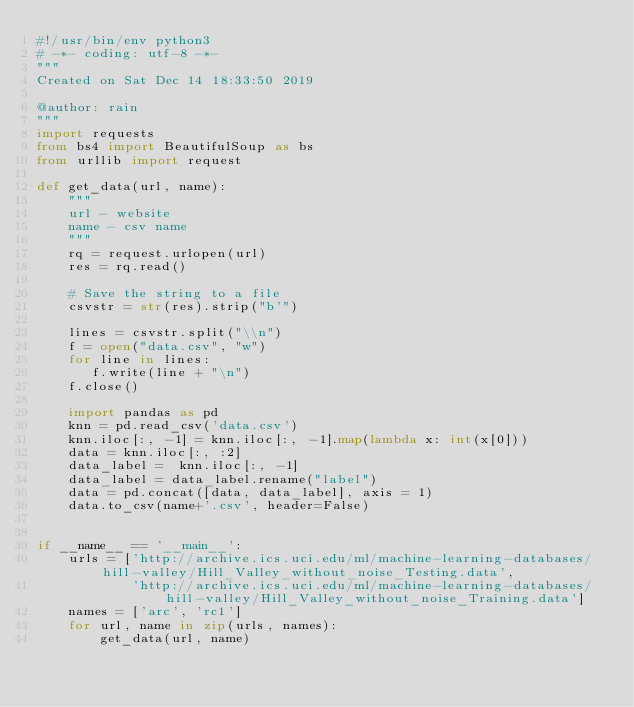<code> <loc_0><loc_0><loc_500><loc_500><_Python_>#!/usr/bin/env python3
# -*- coding: utf-8 -*-
"""
Created on Sat Dec 14 18:33:50 2019

@author: rain
"""
import requests
from bs4 import BeautifulSoup as bs
from urllib import request

def get_data(url, name): 
    """
    url - website
    name - csv name
    """
    rq = request.urlopen(url)
    res = rq.read()
    
    # Save the string to a file
    csvstr = str(res).strip("b'")
    
    lines = csvstr.split("\\n")
    f = open("data.csv", "w")
    for line in lines:
       f.write(line + "\n")
    f.close()
    
    import pandas as pd
    knn = pd.read_csv('data.csv')
    knn.iloc[:, -1] = knn.iloc[:, -1].map(lambda x: int(x[0]))
    data = knn.iloc[:, :2]
    data_label =  knn.iloc[:, -1]
    data_label = data_label.rename("label")
    data = pd.concat([data, data_label], axis = 1)  
    data.to_csv(name+'.csv', header=False)
    

if __name__ == '__main__':
    urls = ['http://archive.ics.uci.edu/ml/machine-learning-databases/hill-valley/Hill_Valley_without_noise_Testing.data', 
            'http://archive.ics.uci.edu/ml/machine-learning-databases/hill-valley/Hill_Valley_without_noise_Training.data']
    names = ['arc', 'rc1']
    for url, name in zip(urls, names):
        get_data(url, name)
        </code> 